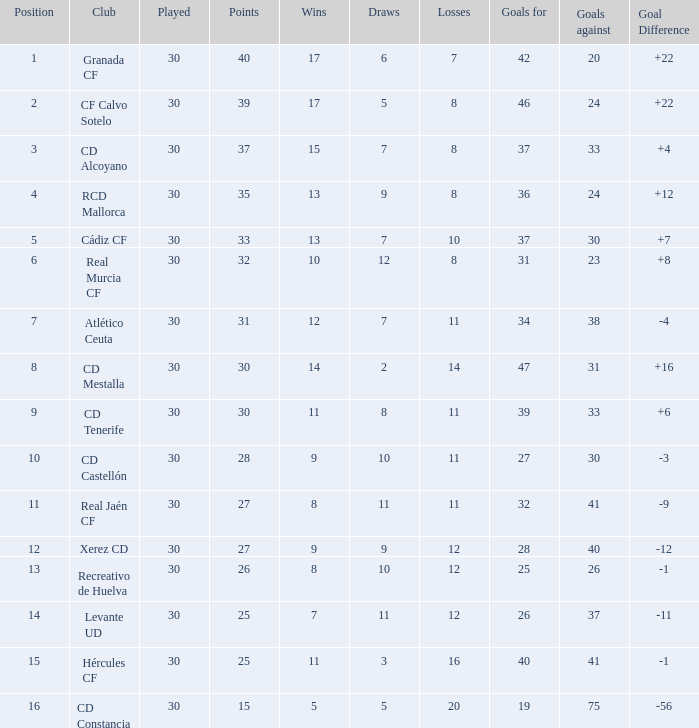How many triumphs have goals conceded fewer than 30, and goals scored over 25, and stalemates exceeding 5? 3.0. 